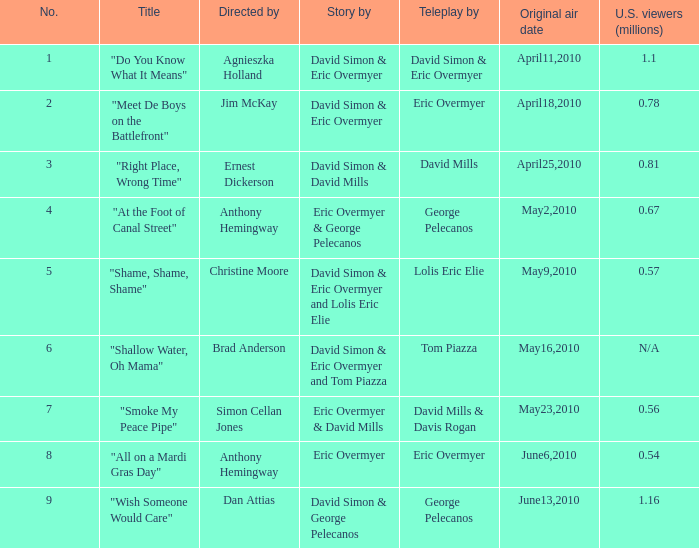Specify the american viewers led by christine moore. 0.57. 